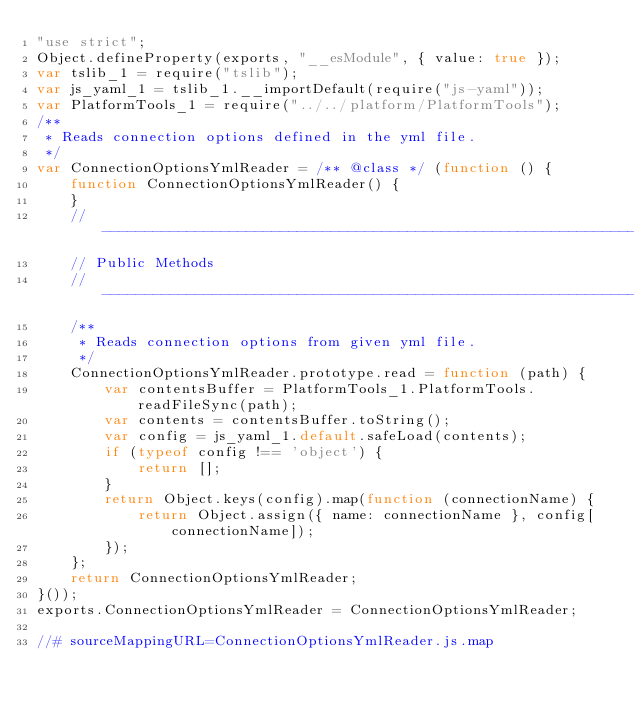<code> <loc_0><loc_0><loc_500><loc_500><_JavaScript_>"use strict";
Object.defineProperty(exports, "__esModule", { value: true });
var tslib_1 = require("tslib");
var js_yaml_1 = tslib_1.__importDefault(require("js-yaml"));
var PlatformTools_1 = require("../../platform/PlatformTools");
/**
 * Reads connection options defined in the yml file.
 */
var ConnectionOptionsYmlReader = /** @class */ (function () {
    function ConnectionOptionsYmlReader() {
    }
    // -------------------------------------------------------------------------
    // Public Methods
    // -------------------------------------------------------------------------
    /**
     * Reads connection options from given yml file.
     */
    ConnectionOptionsYmlReader.prototype.read = function (path) {
        var contentsBuffer = PlatformTools_1.PlatformTools.readFileSync(path);
        var contents = contentsBuffer.toString();
        var config = js_yaml_1.default.safeLoad(contents);
        if (typeof config !== 'object') {
            return [];
        }
        return Object.keys(config).map(function (connectionName) {
            return Object.assign({ name: connectionName }, config[connectionName]);
        });
    };
    return ConnectionOptionsYmlReader;
}());
exports.ConnectionOptionsYmlReader = ConnectionOptionsYmlReader;

//# sourceMappingURL=ConnectionOptionsYmlReader.js.map
</code> 